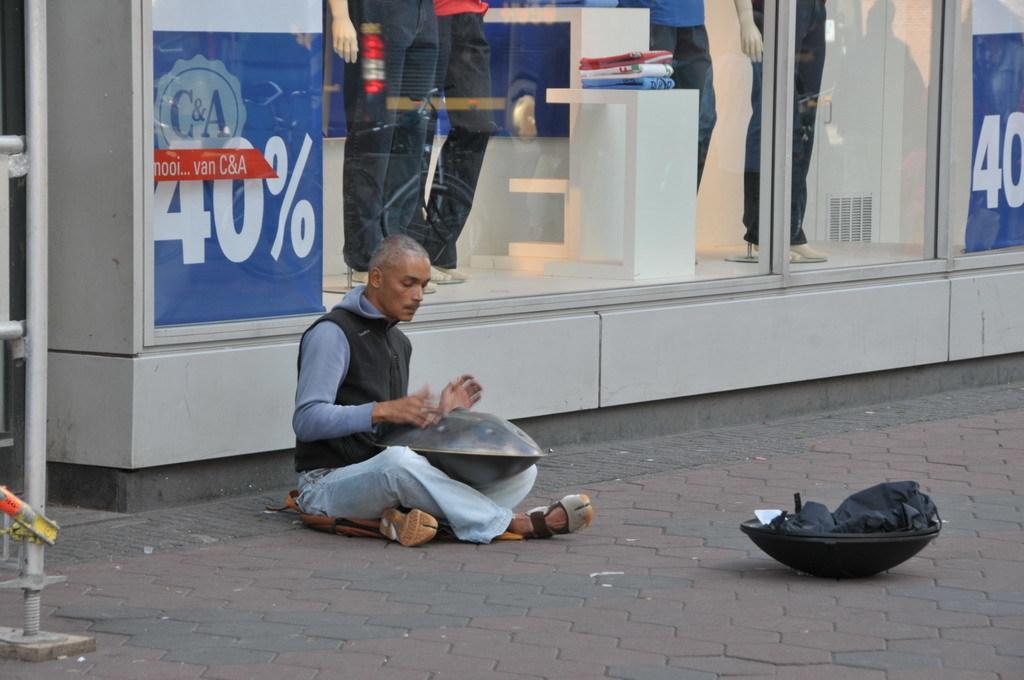Please provide a concise description of this image. In this image I can see a person sitting on the floor and in front of the person I can see pan kept on the floor and person sitting in front of the glass wall ,through wall I can see persons legs , on the left side I can see a stand. 